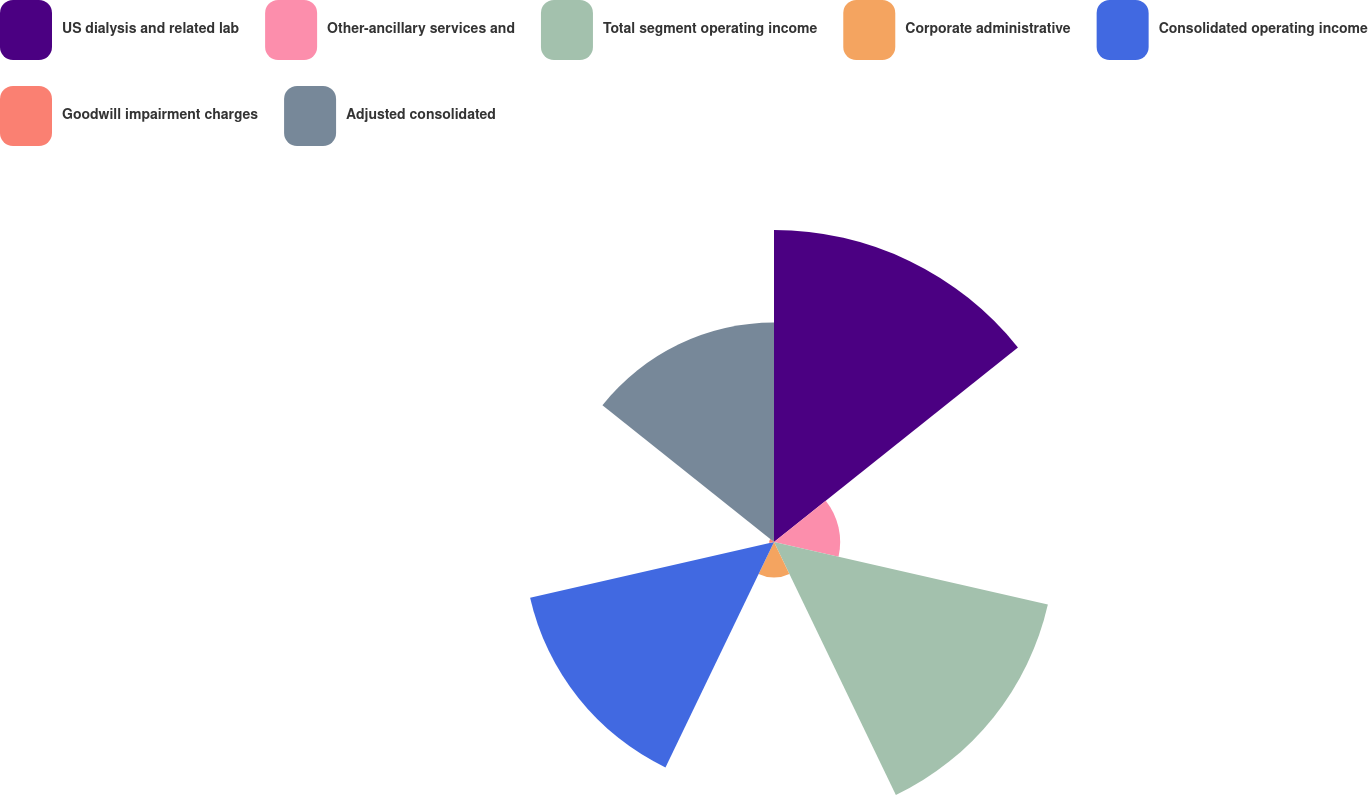Convert chart. <chart><loc_0><loc_0><loc_500><loc_500><pie_chart><fcel>US dialysis and related lab<fcel>Other-ancillary services and<fcel>Total segment operating income<fcel>Corporate administrative<fcel>Consolidated operating income<fcel>Goodwill impairment charges<fcel>Adjusted consolidated<nl><fcel>26.69%<fcel>5.66%<fcel>24.03%<fcel>3.03%<fcel>21.4%<fcel>0.41%<fcel>18.77%<nl></chart> 